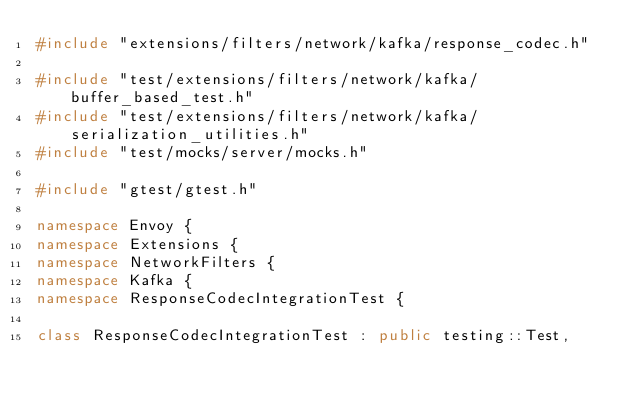<code> <loc_0><loc_0><loc_500><loc_500><_C++_>#include "extensions/filters/network/kafka/response_codec.h"

#include "test/extensions/filters/network/kafka/buffer_based_test.h"
#include "test/extensions/filters/network/kafka/serialization_utilities.h"
#include "test/mocks/server/mocks.h"

#include "gtest/gtest.h"

namespace Envoy {
namespace Extensions {
namespace NetworkFilters {
namespace Kafka {
namespace ResponseCodecIntegrationTest {

class ResponseCodecIntegrationTest : public testing::Test,</code> 